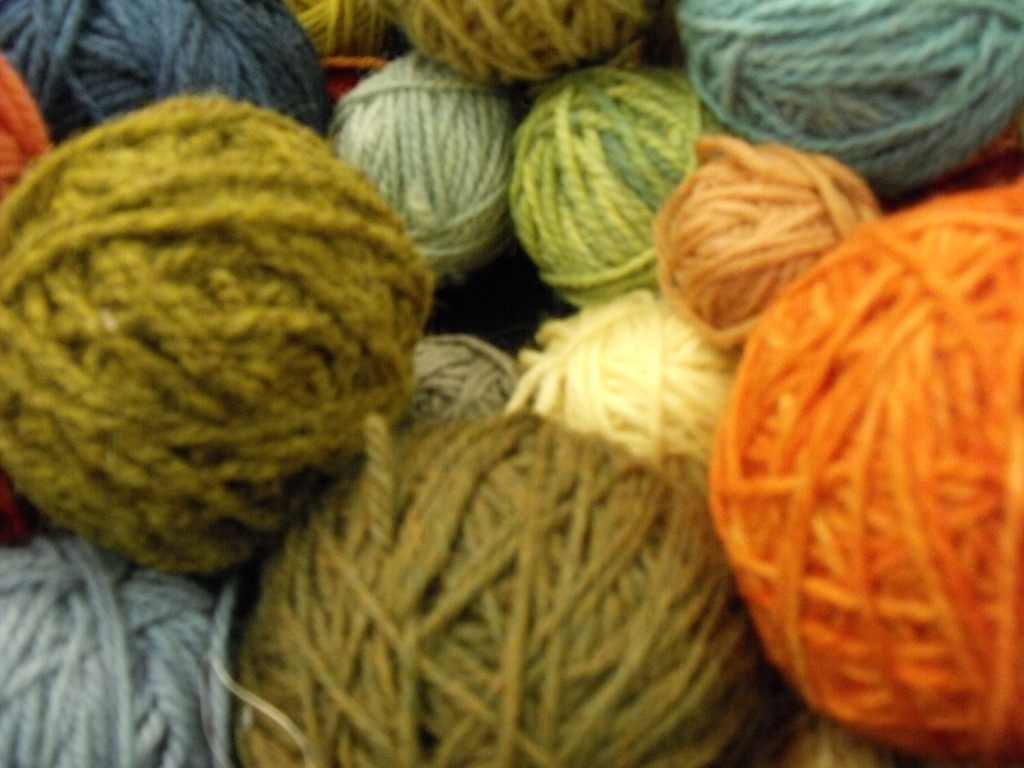How is the focus in this image?
A. excellent
B. very poor
C. exceptional The focus in the image is relatively soft, indicating a possible intentional artistic choice or a technical limitation during capturing the photograph. While the image is not sharply focused, it does not entirely qualify as 'very poor,' since elements in the image are still discernible. A more apt description might be modest or moderate. However, without further context, it's difficult to gauge whether the focus level was an intentional artistic decision. 